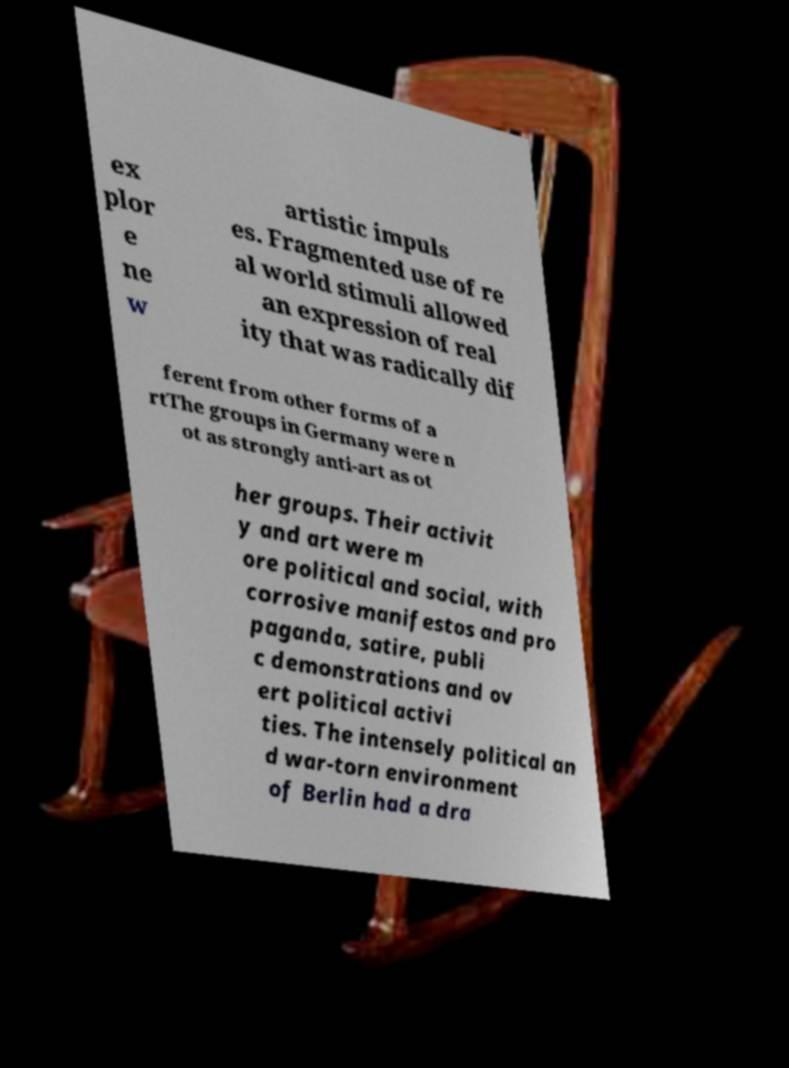I need the written content from this picture converted into text. Can you do that? ex plor e ne w artistic impuls es. Fragmented use of re al world stimuli allowed an expression of real ity that was radically dif ferent from other forms of a rtThe groups in Germany were n ot as strongly anti-art as ot her groups. Their activit y and art were m ore political and social, with corrosive manifestos and pro paganda, satire, publi c demonstrations and ov ert political activi ties. The intensely political an d war-torn environment of Berlin had a dra 